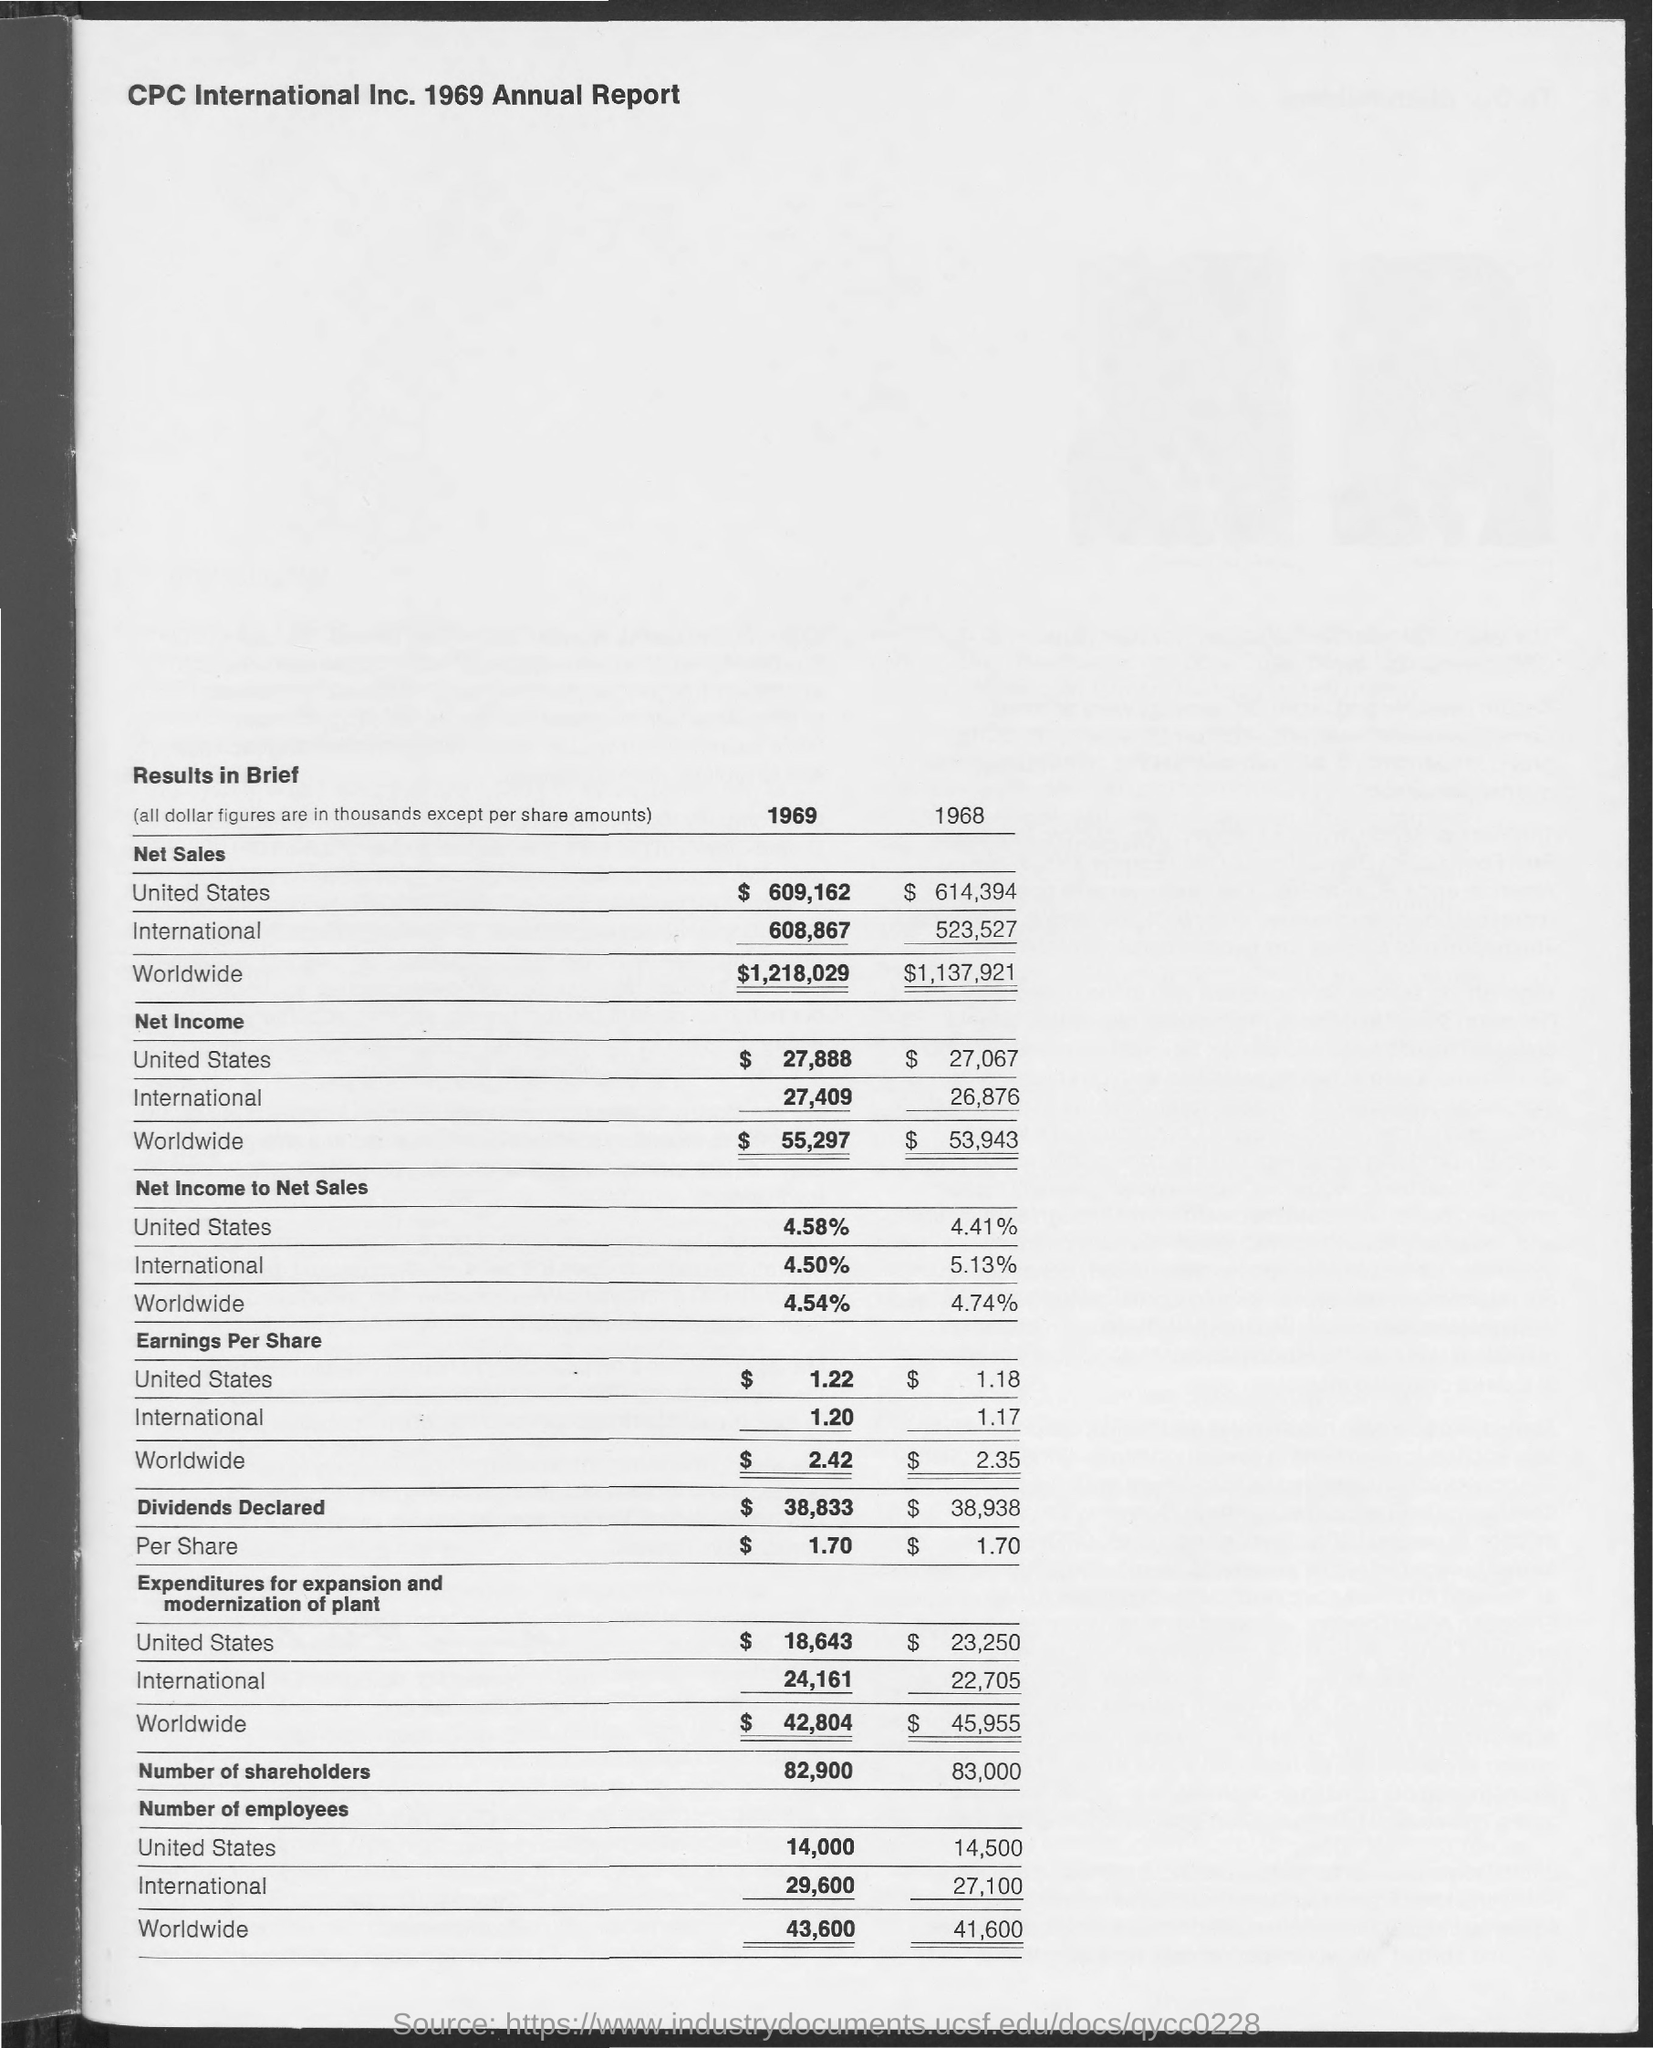What is the worldwide net income of 1969 ?
Keep it short and to the point. $55,297. What is the international earnings per share in 1969 ?
Provide a succinct answer. 1.20. What are the dividends declared in 1969 ?
Give a very brief answer. 38,833. What is the title of the document ?
Make the answer very short. CPC International Inc. 1969 Annual Report. 